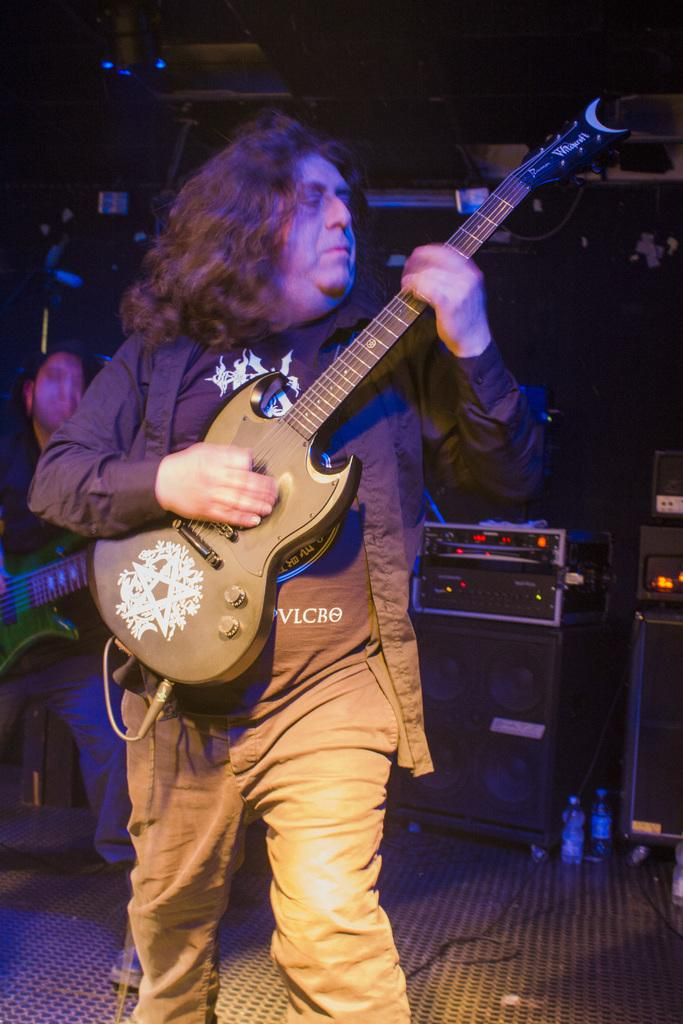What is the main activity being performed by the man in the image? The man in the image is standing and playing a guitar. Can you describe the other man in the image? The other man in the image is holding a guitar. What can be seen in the background of the image? There are speakers and lights in the background of the image. What type of bubble is being blown by the man playing the guitar in the image? There is no bubble present in the image; the man is playing a guitar. 